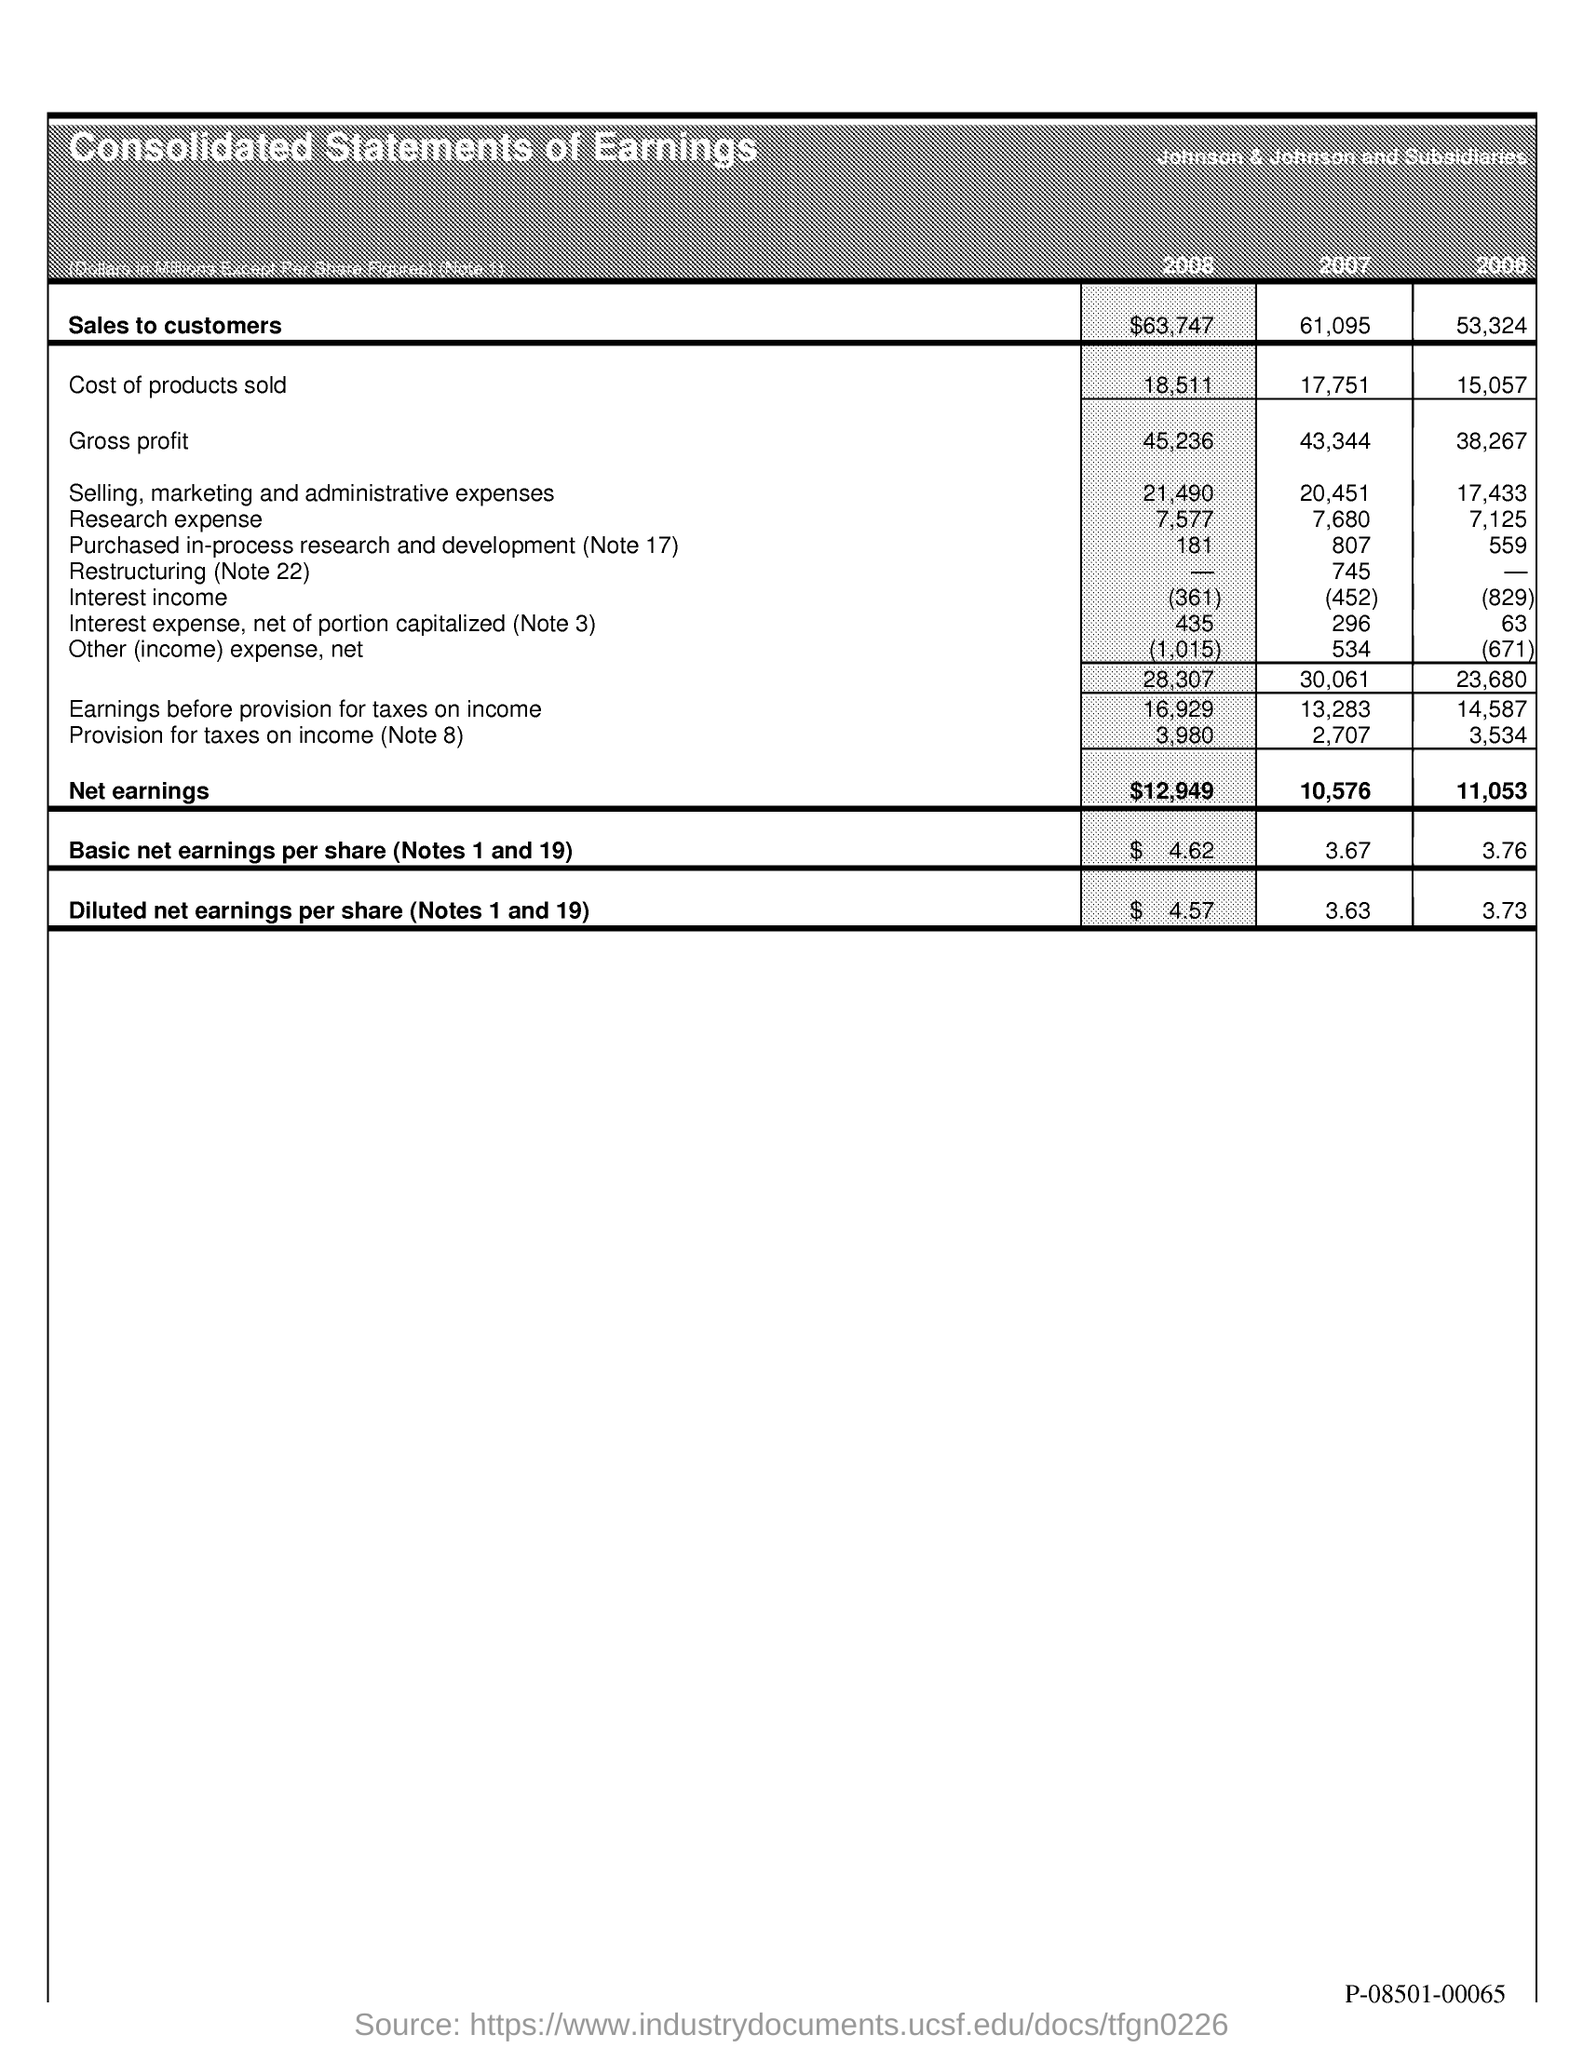What is sales to customers in 2008?
Your answer should be compact. $63,747. What is sales to customers in 2007?
Your answer should be compact. 61,095. What is sales to customers in 2006?
Provide a short and direct response. 53,324. What is cost of products sold in 2008?
Offer a very short reply. 18,511. What is cost of products sold in 2007?
Ensure brevity in your answer.  17,751. What is the cost of products sold in 2006?
Keep it short and to the point. 15,057. What is net earnings in 2008?
Provide a succinct answer. $12,949. What is net earnings in 2007?
Keep it short and to the point. 10,576. What is net earnings in 2006?
Ensure brevity in your answer.  11,053. What is basic net earnings per share ( note 1 and 19) in 2008?
Offer a terse response. $4.62. 